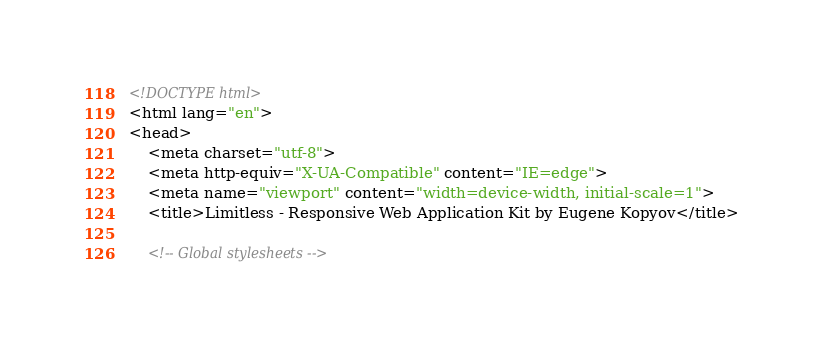Convert code to text. <code><loc_0><loc_0><loc_500><loc_500><_HTML_><!DOCTYPE html>
<html lang="en">
<head>
	<meta charset="utf-8">
	<meta http-equiv="X-UA-Compatible" content="IE=edge">
	<meta name="viewport" content="width=device-width, initial-scale=1">
	<title>Limitless - Responsive Web Application Kit by Eugene Kopyov</title>

	<!-- Global stylesheets --></code> 